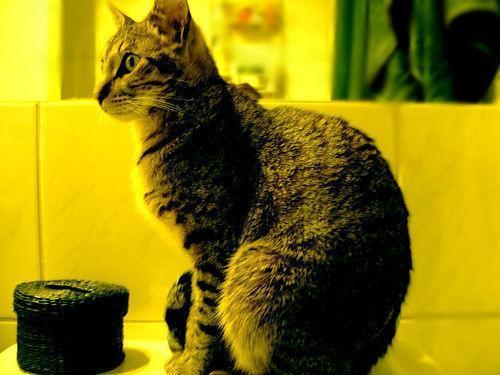How many cats are in the photo?
Give a very brief answer. 1. 